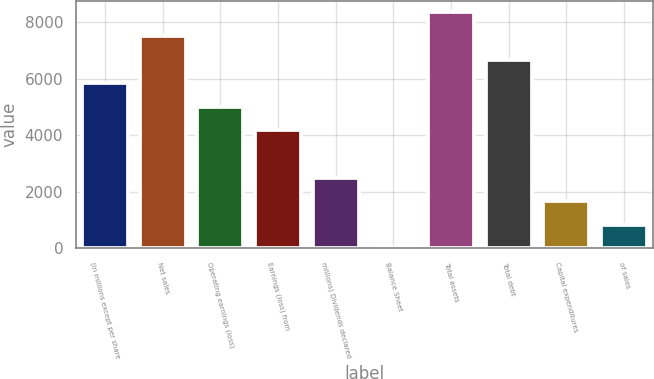Convert chart. <chart><loc_0><loc_0><loc_500><loc_500><bar_chart><fcel>(In millions except per share<fcel>Net sales<fcel>Operating earnings (loss)<fcel>Earnings (loss) from<fcel>millions) Dividends declared<fcel>Balance Sheet<fcel>Total assets<fcel>Total debt<fcel>Capital expenditures<fcel>of sales<nl><fcel>5842.65<fcel>7511.57<fcel>5008.19<fcel>4173.73<fcel>2504.81<fcel>1.43<fcel>8346.03<fcel>6677.11<fcel>1670.35<fcel>835.89<nl></chart> 